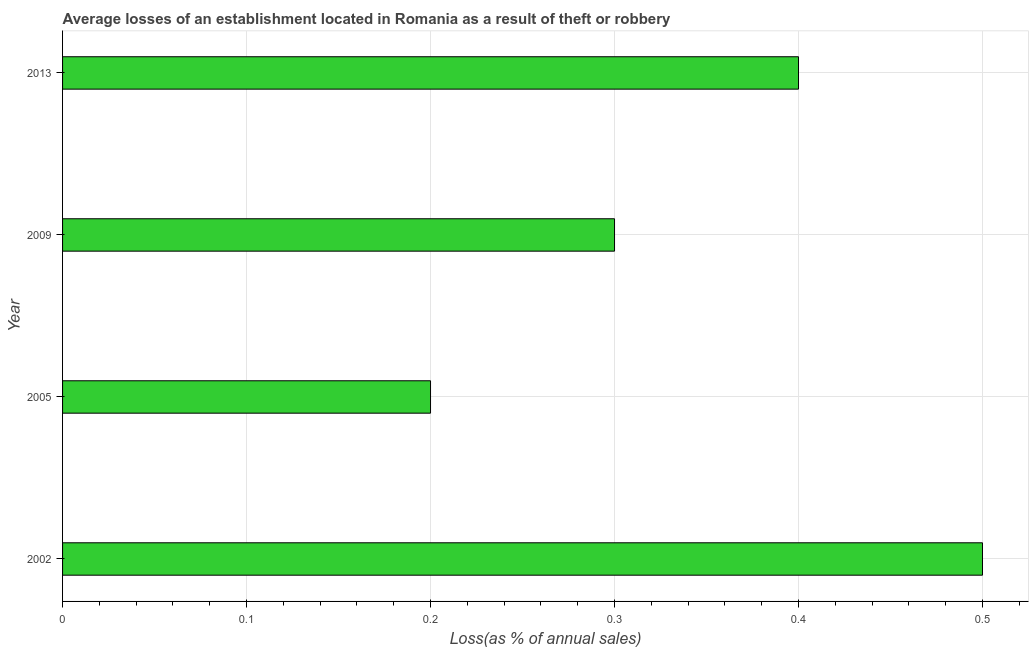Does the graph contain grids?
Make the answer very short. Yes. What is the title of the graph?
Your answer should be compact. Average losses of an establishment located in Romania as a result of theft or robbery. What is the label or title of the X-axis?
Offer a terse response. Loss(as % of annual sales). What is the label or title of the Y-axis?
Provide a short and direct response. Year. In which year was the losses due to theft maximum?
Offer a very short reply. 2002. What is the average losses due to theft per year?
Your answer should be compact. 0.35. What is the median losses due to theft?
Keep it short and to the point. 0.35. Do a majority of the years between 2002 and 2009 (inclusive) have losses due to theft greater than 0.32 %?
Ensure brevity in your answer.  No. What is the ratio of the losses due to theft in 2009 to that in 2013?
Your answer should be very brief. 0.75. Is the losses due to theft in 2002 less than that in 2005?
Your response must be concise. No. Is the difference between the losses due to theft in 2005 and 2009 greater than the difference between any two years?
Offer a very short reply. No. Are all the bars in the graph horizontal?
Your answer should be compact. Yes. How many years are there in the graph?
Provide a short and direct response. 4. What is the difference between two consecutive major ticks on the X-axis?
Offer a terse response. 0.1. What is the Loss(as % of annual sales) in 2002?
Give a very brief answer. 0.5. What is the Loss(as % of annual sales) of 2005?
Offer a terse response. 0.2. What is the Loss(as % of annual sales) in 2009?
Offer a very short reply. 0.3. What is the Loss(as % of annual sales) in 2013?
Provide a short and direct response. 0.4. What is the difference between the Loss(as % of annual sales) in 2002 and 2009?
Keep it short and to the point. 0.2. What is the difference between the Loss(as % of annual sales) in 2005 and 2013?
Your answer should be very brief. -0.2. What is the ratio of the Loss(as % of annual sales) in 2002 to that in 2005?
Make the answer very short. 2.5. What is the ratio of the Loss(as % of annual sales) in 2002 to that in 2009?
Offer a very short reply. 1.67. What is the ratio of the Loss(as % of annual sales) in 2005 to that in 2009?
Ensure brevity in your answer.  0.67. What is the ratio of the Loss(as % of annual sales) in 2005 to that in 2013?
Ensure brevity in your answer.  0.5. What is the ratio of the Loss(as % of annual sales) in 2009 to that in 2013?
Offer a very short reply. 0.75. 